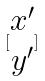<formula> <loc_0><loc_0><loc_500><loc_500>[ \begin{matrix} x ^ { \prime } \\ y ^ { \prime } \end{matrix} ]</formula> 